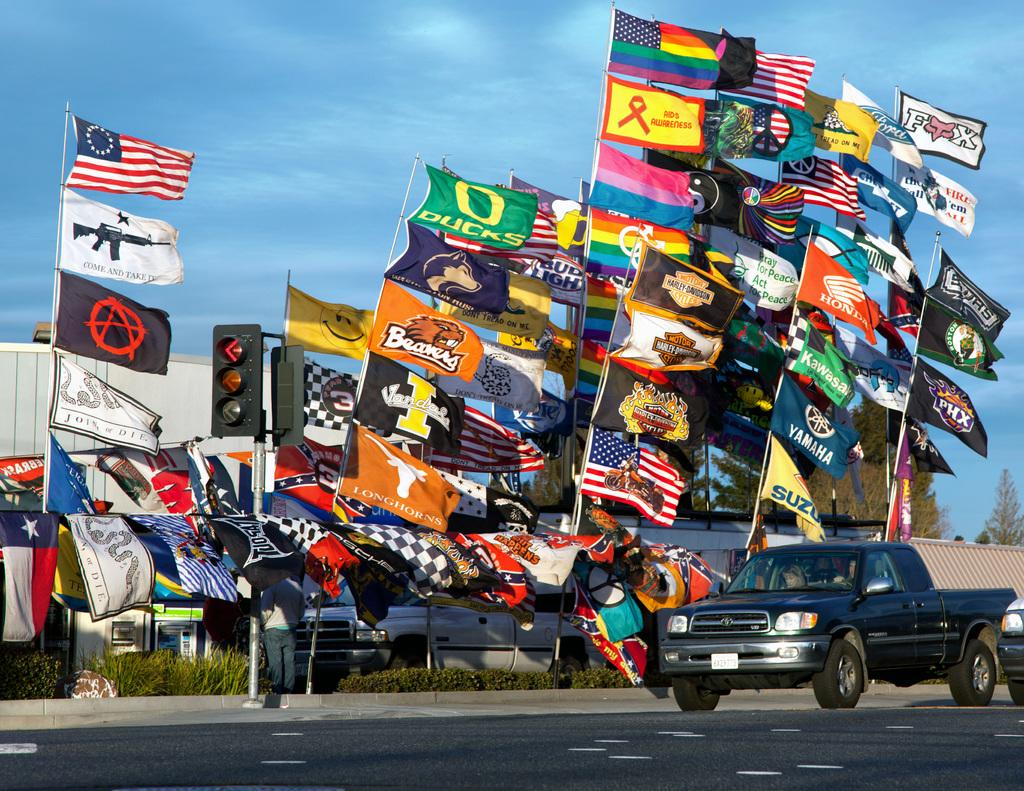What is the main subject of the image? The main subject of the image is a vehicle on the road. Can you describe another vehicle in the image? Yes, there is another vehicle on the side of the road. What is the person in the image doing? The person is standing in front of houses. What decorative elements can be seen in the image? Flags and signal lights are visible in the image. What type of vegetation is present in the image? Trees are present in the image. What time of day is it in the image, and how does the person feel about the afternoon? The time of day cannot be determined from the image, and there is no information about the person's feelings towards the afternoon. Is there a park visible in the image? No, there is no park present in the image. 